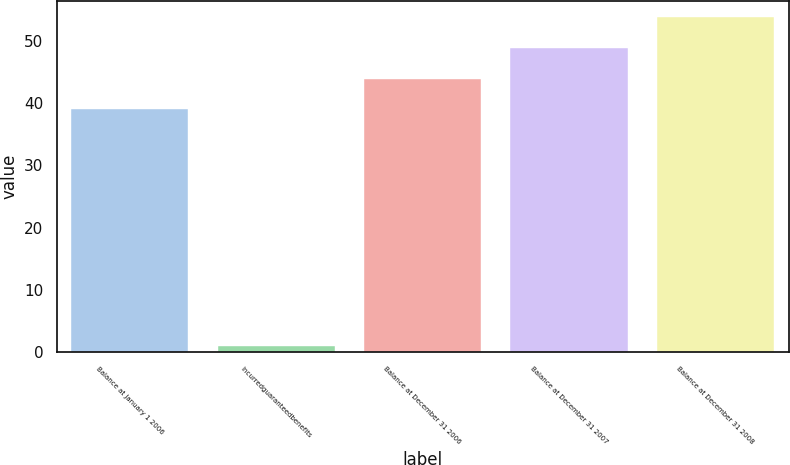Convert chart. <chart><loc_0><loc_0><loc_500><loc_500><bar_chart><fcel>Balance at January 1 2006<fcel>Incurredguaranteedbenefits<fcel>Balance at December 31 2006<fcel>Balance at December 31 2007<fcel>Balance at December 31 2008<nl><fcel>39<fcel>1<fcel>43.9<fcel>48.8<fcel>53.7<nl></chart> 